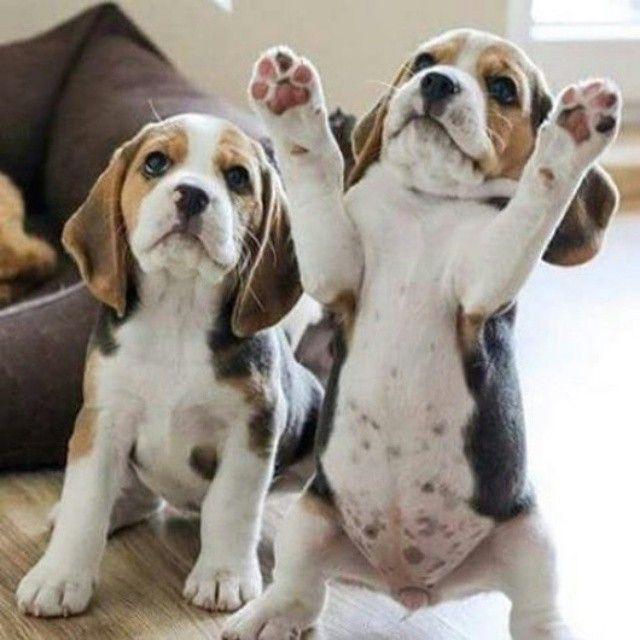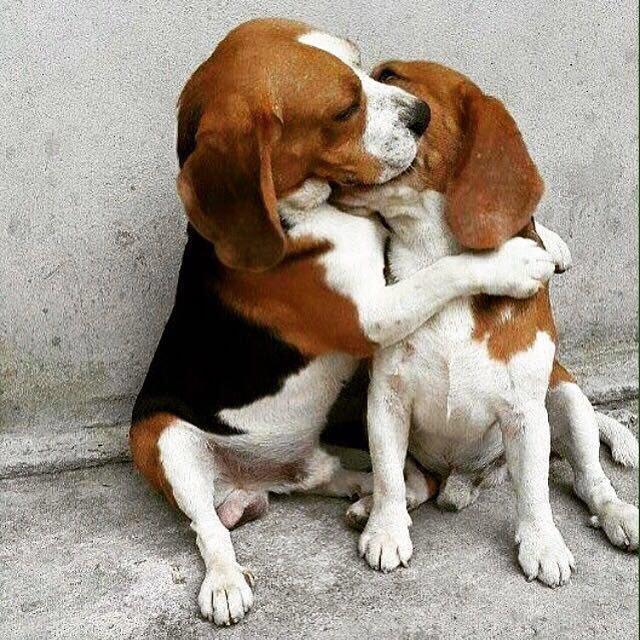The first image is the image on the left, the second image is the image on the right. Examine the images to the left and right. Is the description "The left image contains exactly two puppies." accurate? Answer yes or no. Yes. The first image is the image on the left, the second image is the image on the right. For the images shown, is this caption "Two dogs pose together in the image on the left." true? Answer yes or no. Yes. 